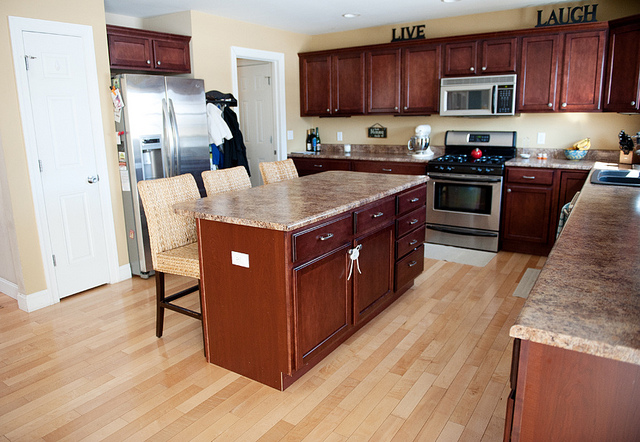Identify the text displayed in this image. LIVE LAUGH 